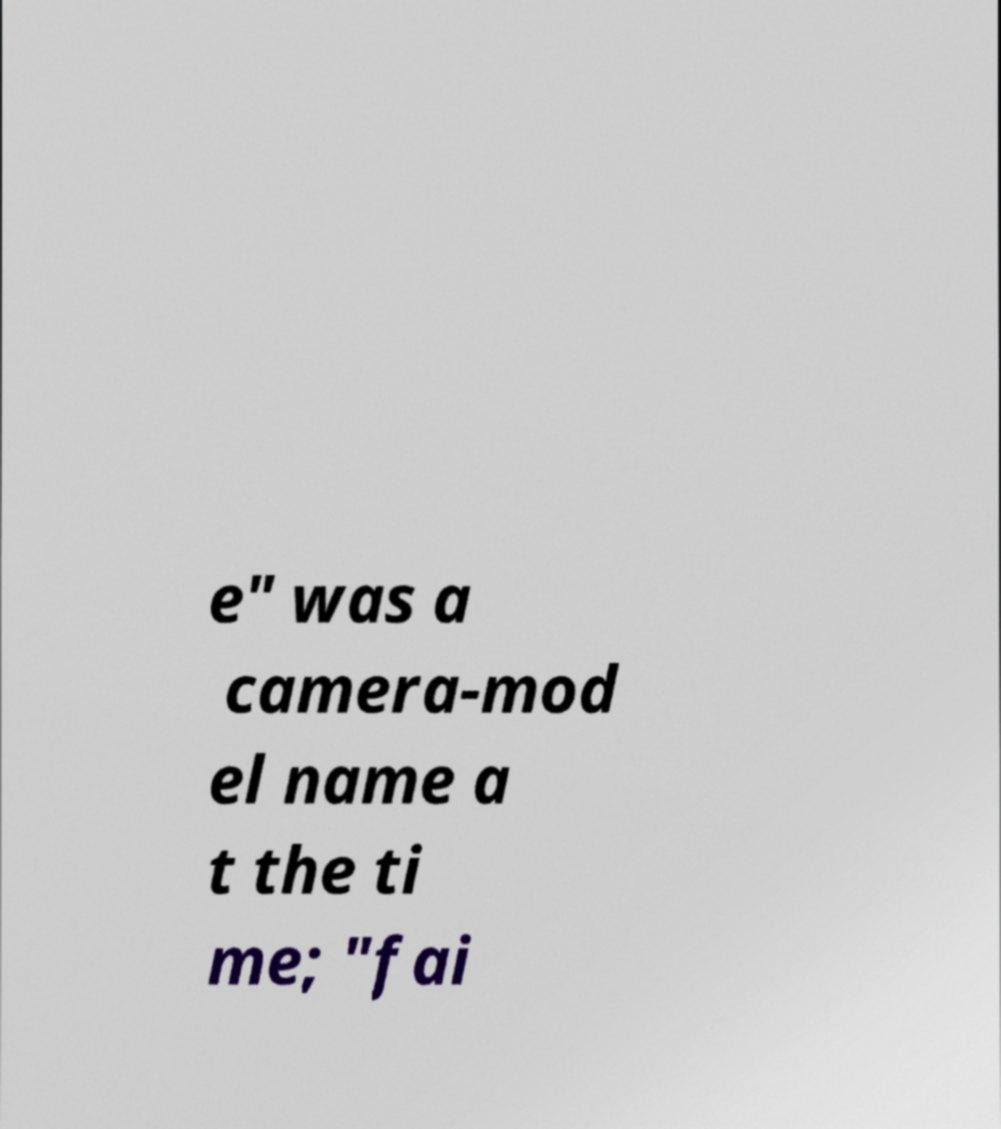Can you accurately transcribe the text from the provided image for me? e" was a camera-mod el name a t the ti me; "fai 